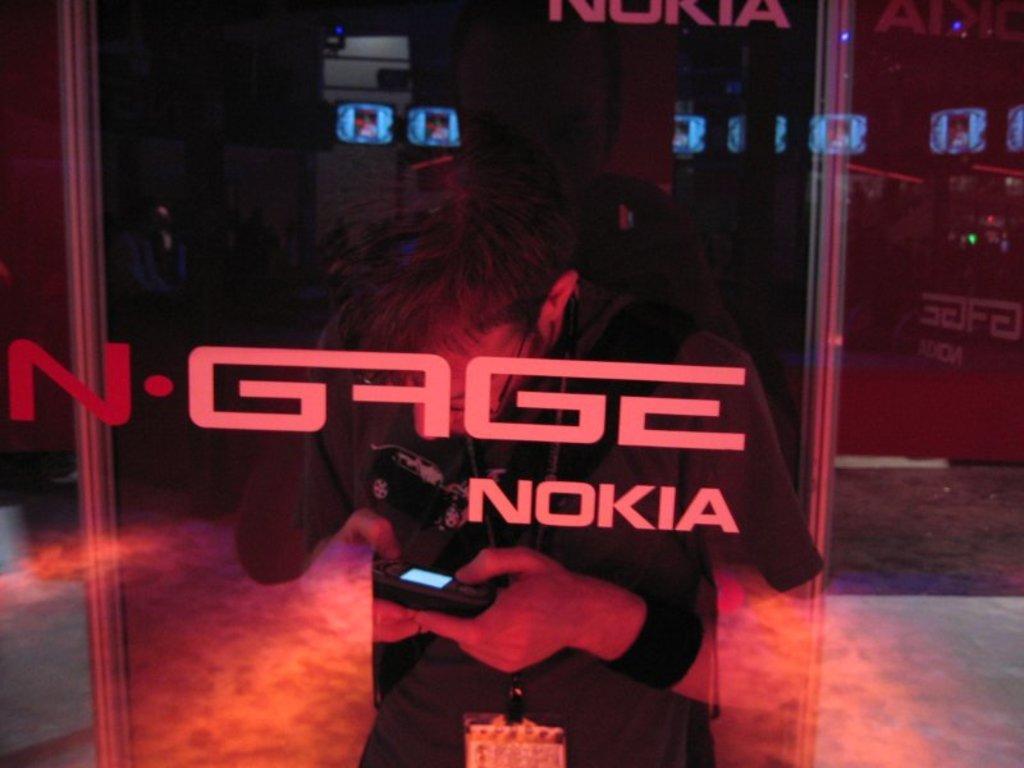Describe this image in one or two sentences. In this image I can see the person holding the black color object and the person wearing the black color dress. In-front of the person I can see the glass and the name Nokia is written on it. And there is a black background. 